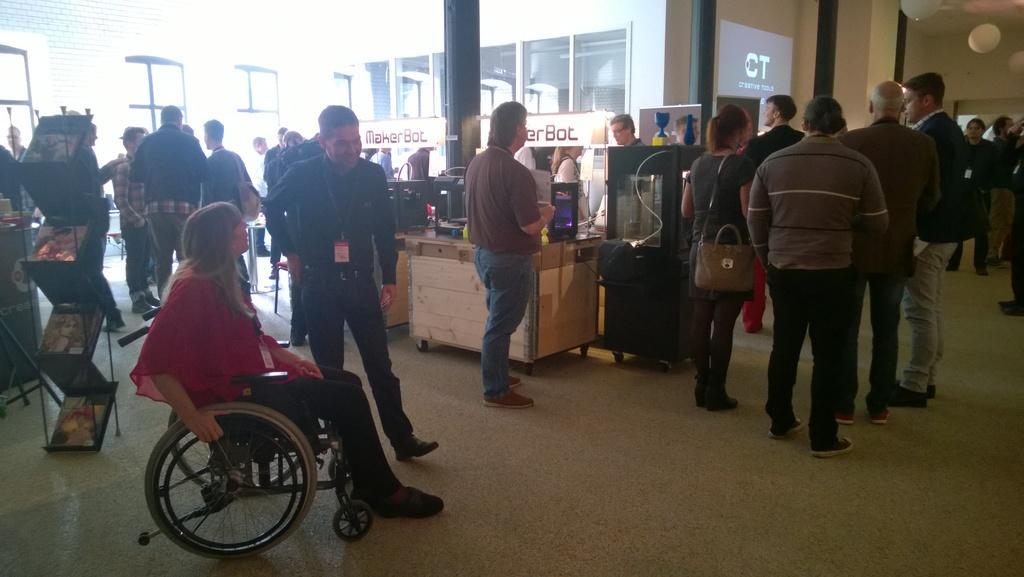Could you give a brief overview of what you see in this image? In the image there are many people standing and walking on the floor, there is woman sitting on wheel chair on left side, in the back there are glass windows on the wall with a table in front of it and desktop on it. 